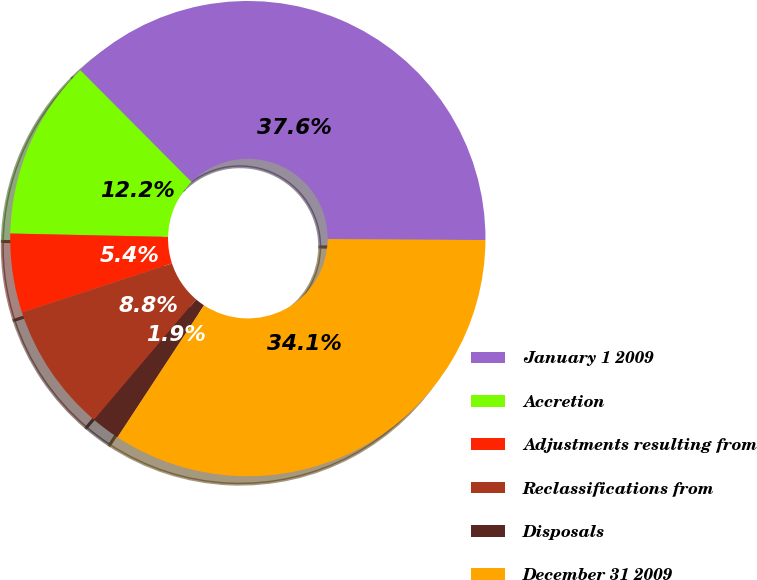Convert chart to OTSL. <chart><loc_0><loc_0><loc_500><loc_500><pie_chart><fcel>January 1 2009<fcel>Accretion<fcel>Adjustments resulting from<fcel>Reclassifications from<fcel>Disposals<fcel>December 31 2009<nl><fcel>37.56%<fcel>12.2%<fcel>5.37%<fcel>8.78%<fcel>1.95%<fcel>34.15%<nl></chart> 